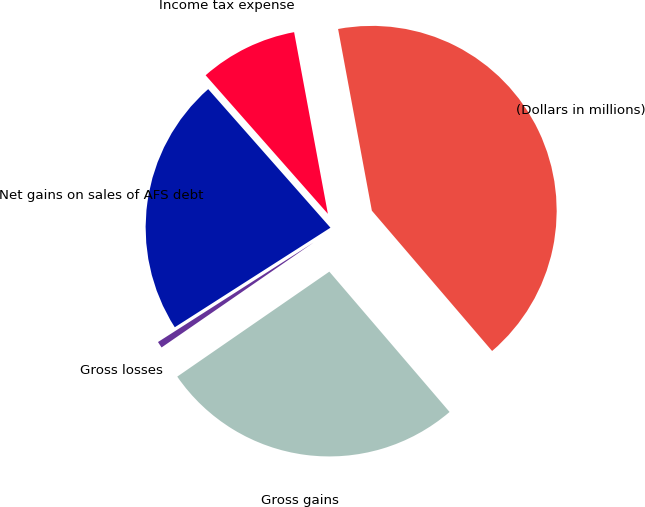Convert chart. <chart><loc_0><loc_0><loc_500><loc_500><pie_chart><fcel>(Dollars in millions)<fcel>Gross gains<fcel>Gross losses<fcel>Net gains on sales of AFS debt<fcel>Income tax expense<nl><fcel>41.65%<fcel>26.66%<fcel>0.56%<fcel>22.55%<fcel>8.58%<nl></chart> 